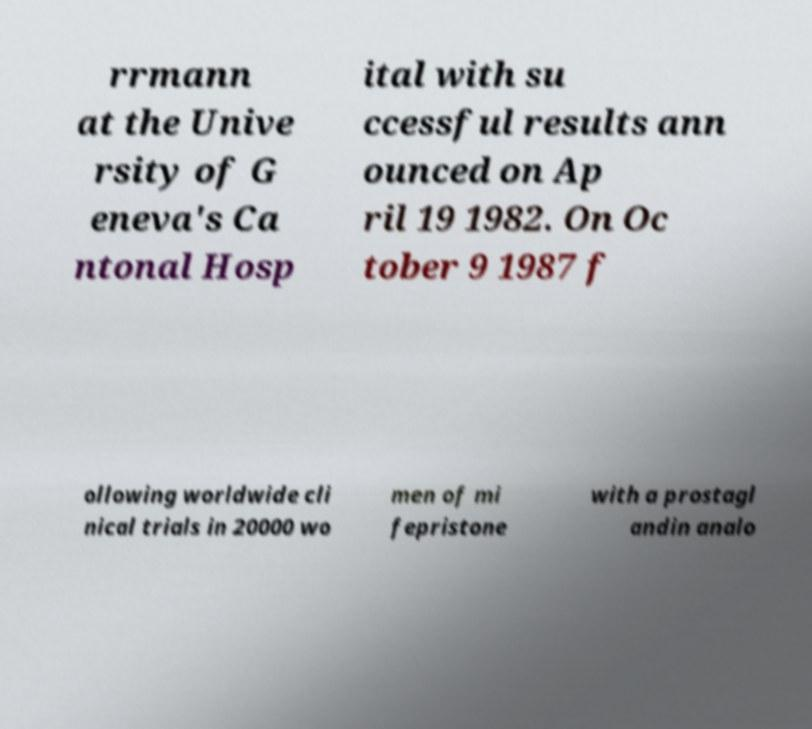Can you read and provide the text displayed in the image?This photo seems to have some interesting text. Can you extract and type it out for me? rrmann at the Unive rsity of G eneva's Ca ntonal Hosp ital with su ccessful results ann ounced on Ap ril 19 1982. On Oc tober 9 1987 f ollowing worldwide cli nical trials in 20000 wo men of mi fepristone with a prostagl andin analo 